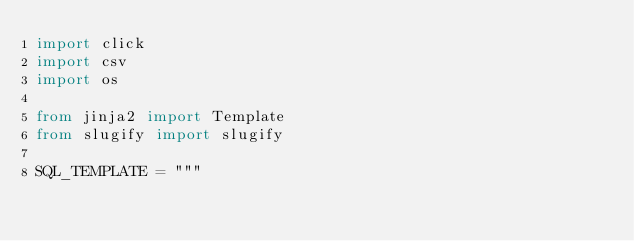Convert code to text. <code><loc_0><loc_0><loc_500><loc_500><_Python_>import click
import csv
import os

from jinja2 import Template
from slugify import slugify

SQL_TEMPLATE = """</code> 